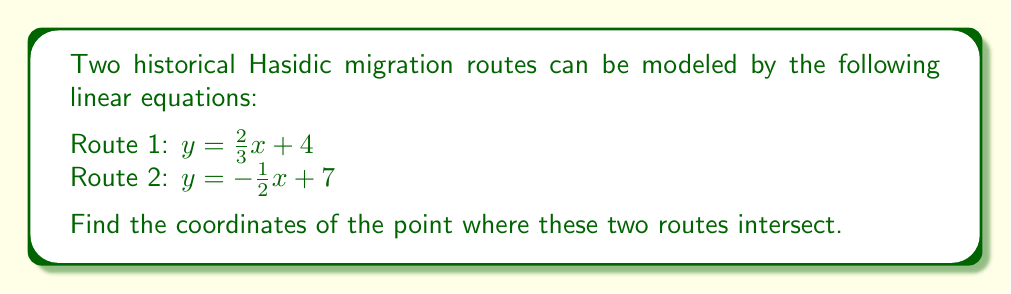Provide a solution to this math problem. To find the point of intersection between these two Hasidic migration routes, we need to solve the system of equations:

$$\begin{cases}
y = \frac{2}{3}x + 4 \\
y = -\frac{1}{2}x + 7
\end{cases}$$

Step 1: Set the two equations equal to each other since they represent the same y-coordinate at the point of intersection.

$$\frac{2}{3}x + 4 = -\frac{1}{2}x + 7$$

Step 2: Solve for x by isolating all terms with x on one side and constants on the other.

$$\frac{2}{3}x + \frac{1}{2}x = 7 - 4$$
$$\frac{2}{3}x + \frac{1}{2}x = 3$$

Step 3: Find a common denominator (6) and add the fractions on the left side.

$$\frac{4}{6}x + \frac{3}{6}x = 3$$
$$\frac{7}{6}x = 3$$

Step 4: Multiply both sides by 6 to isolate x.

$$7x = 18$$
$$x = \frac{18}{7} \approx 2.57$$

Step 5: Substitute this x-value into either of the original equations to find y. Let's use the first equation:

$$y = \frac{2}{3}(\frac{18}{7}) + 4$$
$$y = \frac{12}{7} + 4$$
$$y = \frac{12}{7} + \frac{28}{7}$$
$$y = \frac{40}{7} \approx 5.71$$

Therefore, the point of intersection is $(\frac{18}{7}, \frac{40}{7})$ or approximately (2.57, 5.71).

[asy]
import geometry;

size(200);
real xmin = -1, xmax = 6, ymin = 0, ymax = 8;
draw((xmin,2/3*xmin+4)--(xmax,2/3*xmax+4), blue);
draw((xmin,-1/2*xmin+7)--(xmax,-1/2*xmax+7), red);
dot((18/7,40/7), black);
label("(18/7, 40/7)", (18/7,40/7), NE);
xaxis(xmin, xmax, Arrow);
yaxis(ymin, ymax, Arrow);
label("Route 1", (5,7.5), blue);
label("Route 2", (5,4.5), red);
[/asy]
Answer: The point of intersection is $(\frac{18}{7}, \frac{40}{7})$ or approximately (2.57, 5.71). 